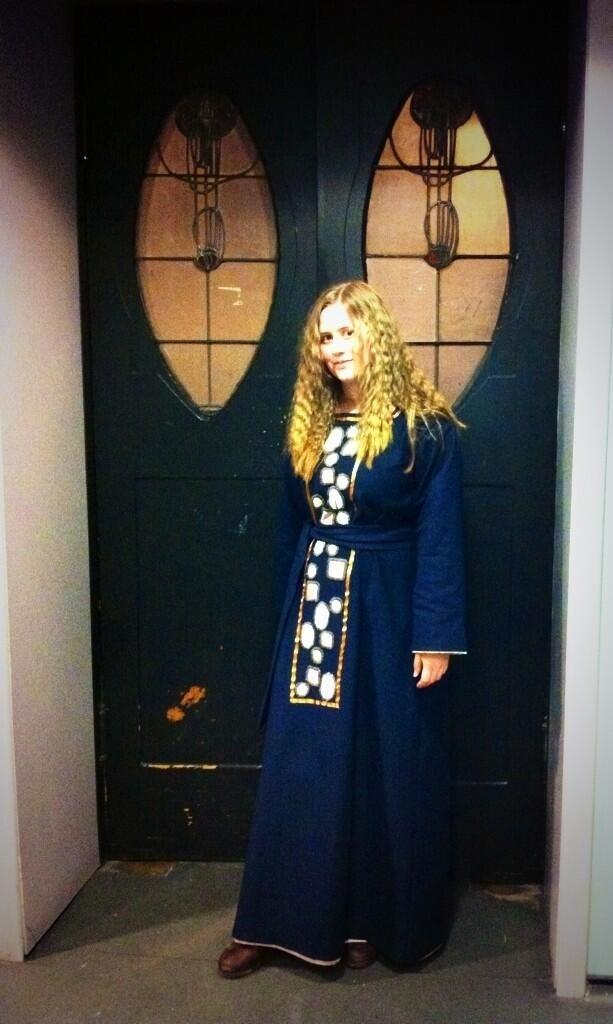What is the woman in the image doing? The woman is standing in the image and smiling. What can be seen behind the woman in the image? There is a wall in the image. Is there any architectural feature with glass in the image? Yes, there is a door with glass in the image. What type of maid is depicted in the image? There is no maid present in the image; it features a woman standing and smiling. What symbol of peace can be seen in the image? There is no symbol of peace depicted in the image. 